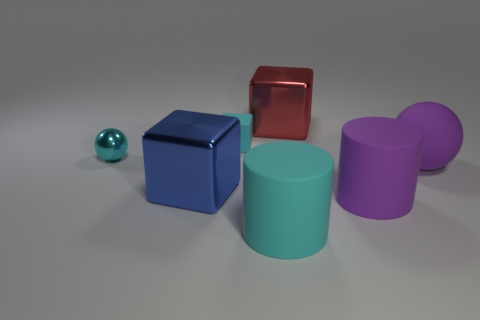The shiny sphere is what color?
Keep it short and to the point. Cyan. What number of other things are the same size as the purple rubber ball?
Offer a terse response. 4. There is a blue object that is the same shape as the small cyan matte object; what material is it?
Offer a very short reply. Metal. The large block behind the matte object that is on the right side of the big matte cylinder that is to the right of the red shiny object is made of what material?
Your response must be concise. Metal. There is a cube that is the same material as the cyan cylinder; what is its size?
Make the answer very short. Small. Is there any other thing that has the same color as the large sphere?
Make the answer very short. Yes. There is a cube right of the small cyan matte object; is it the same color as the ball on the right side of the tiny metallic sphere?
Keep it short and to the point. No. What color is the metal cube in front of the purple rubber sphere?
Your answer should be very brief. Blue. Do the sphere that is left of the red metallic thing and the cyan rubber block have the same size?
Make the answer very short. Yes. Are there fewer things than large shiny blocks?
Keep it short and to the point. No. 